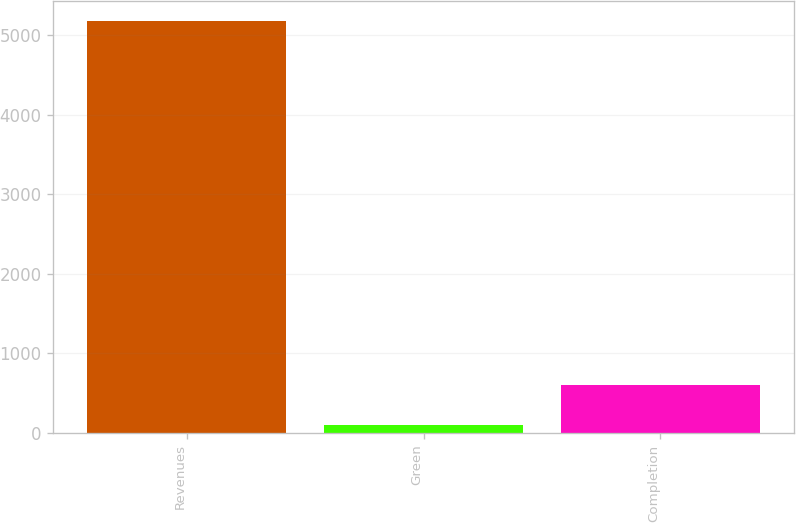<chart> <loc_0><loc_0><loc_500><loc_500><bar_chart><fcel>Revenues<fcel>Green<fcel>Completion<nl><fcel>5171<fcel>94<fcel>601.7<nl></chart> 